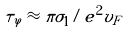<formula> <loc_0><loc_0><loc_500><loc_500>\tau _ { \varphi } \approx \pi \sigma _ { 1 } / e ^ { 2 } v _ { F }</formula> 